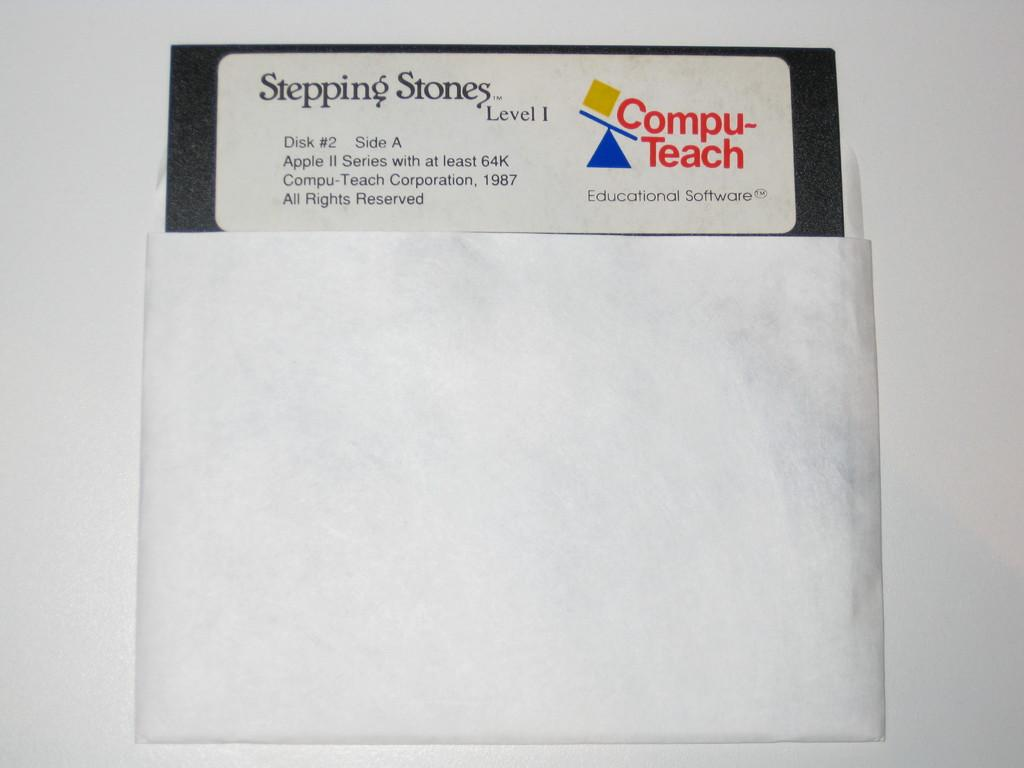What object is visible in the image? There is a white envelope in the image. What is inside the envelope? There is a pamphlet inside the envelope. What type of vegetable is being served for breakfast in the image? There is no vegetable or breakfast scene present in the image; it only features a white envelope with a pamphlet inside. 